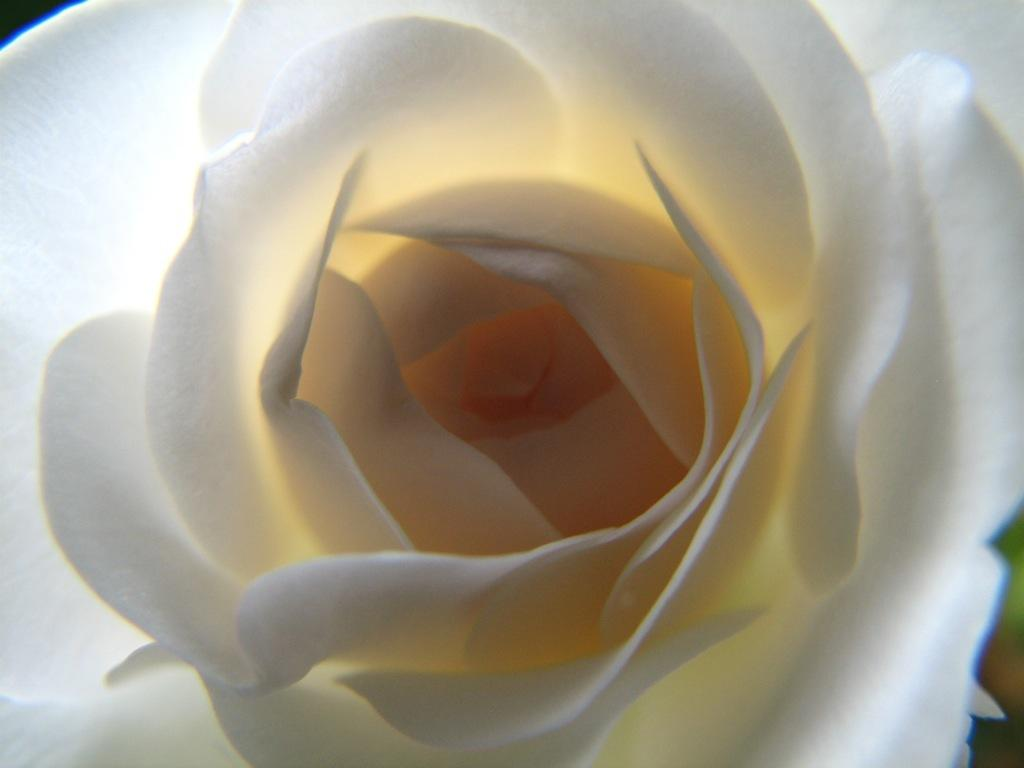What type of flower is in the image? There is a white rose in the image. How is the white rose described? The white rose is described as beautiful. What type of appliance is being used by the stranger in the image? There is no stranger or appliance present in the image; it only features a white rose. 